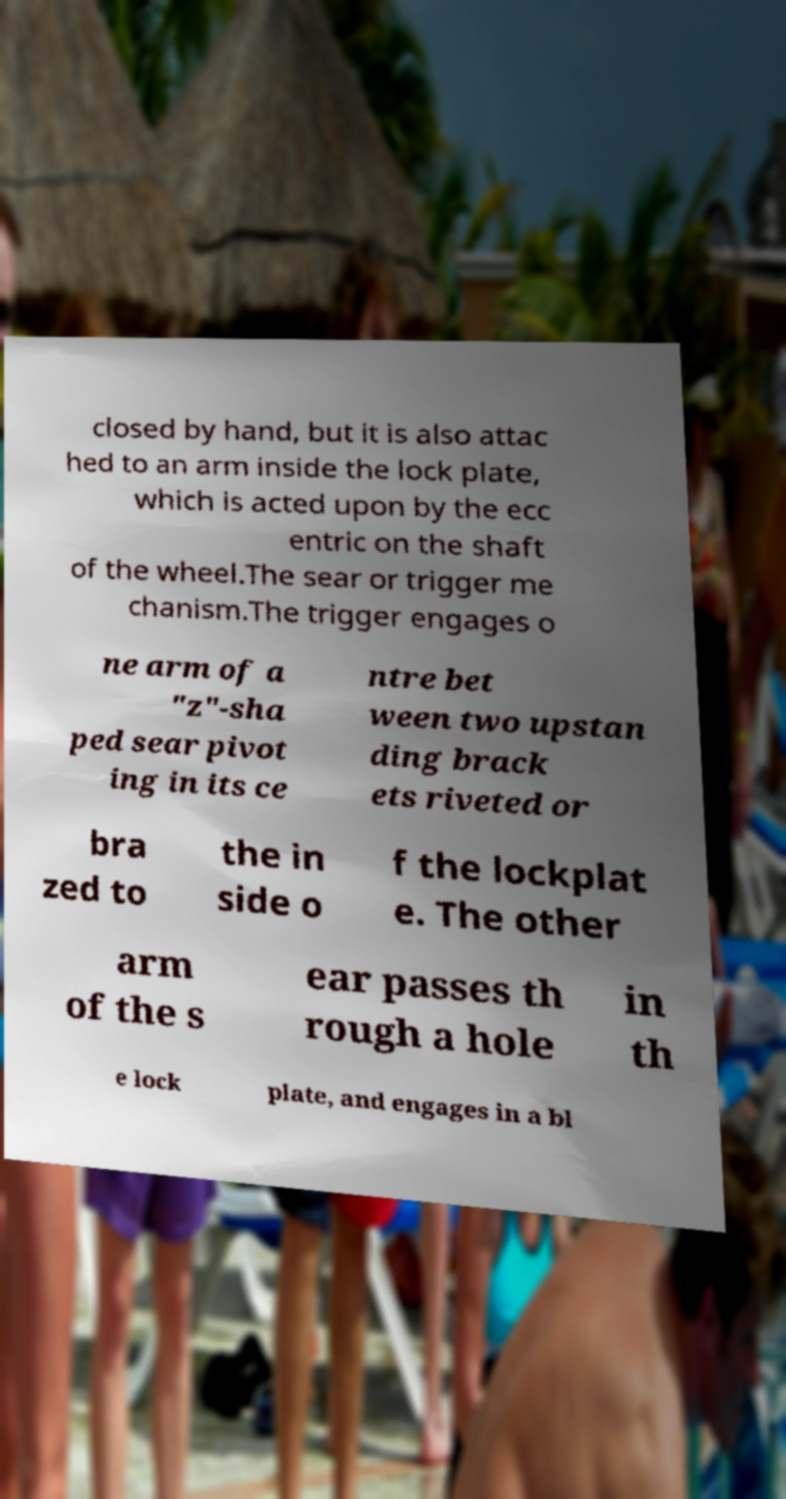Please read and relay the text visible in this image. What does it say? closed by hand, but it is also attac hed to an arm inside the lock plate, which is acted upon by the ecc entric on the shaft of the wheel.The sear or trigger me chanism.The trigger engages o ne arm of a "z"-sha ped sear pivot ing in its ce ntre bet ween two upstan ding brack ets riveted or bra zed to the in side o f the lockplat e. The other arm of the s ear passes th rough a hole in th e lock plate, and engages in a bl 